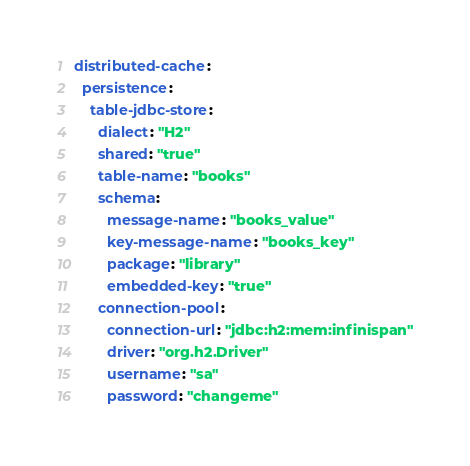Convert code to text. <code><loc_0><loc_0><loc_500><loc_500><_YAML_>distributed-cache:
  persistence:
    table-jdbc-store:
      dialect: "H2"
      shared: "true"
      table-name: "books"
      schema:
        message-name: "books_value"
        key-message-name: "books_key"
        package: "library"
        embedded-key: "true"
      connection-pool:
        connection-url: "jdbc:h2:mem:infinispan"
        driver: "org.h2.Driver"
        username: "sa"
        password: "changeme"
</code> 